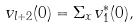<formula> <loc_0><loc_0><loc_500><loc_500>v _ { l + 2 } ( 0 ) = \Sigma _ { x } v _ { 1 } ^ { \ast } ( 0 ) ,</formula> 